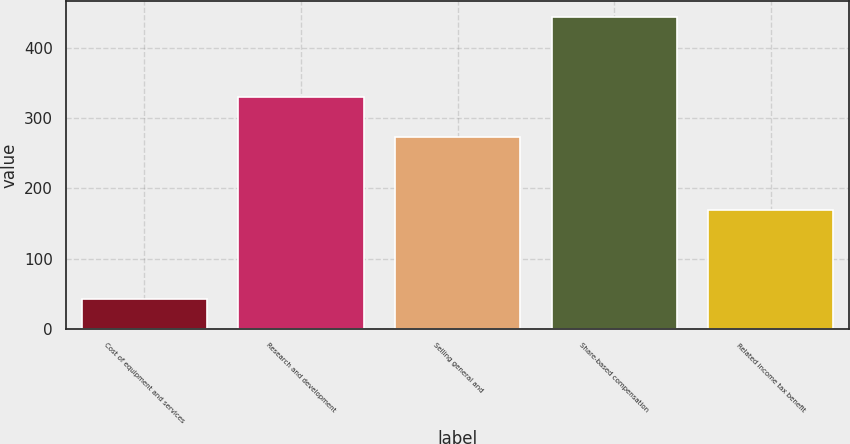<chart> <loc_0><loc_0><loc_500><loc_500><bar_chart><fcel>Cost of equipment and services<fcel>Research and development<fcel>Selling general and<fcel>Share-based compensation<fcel>Related income tax benefit<nl><fcel>42<fcel>330.3<fcel>273<fcel>445<fcel>170<nl></chart> 